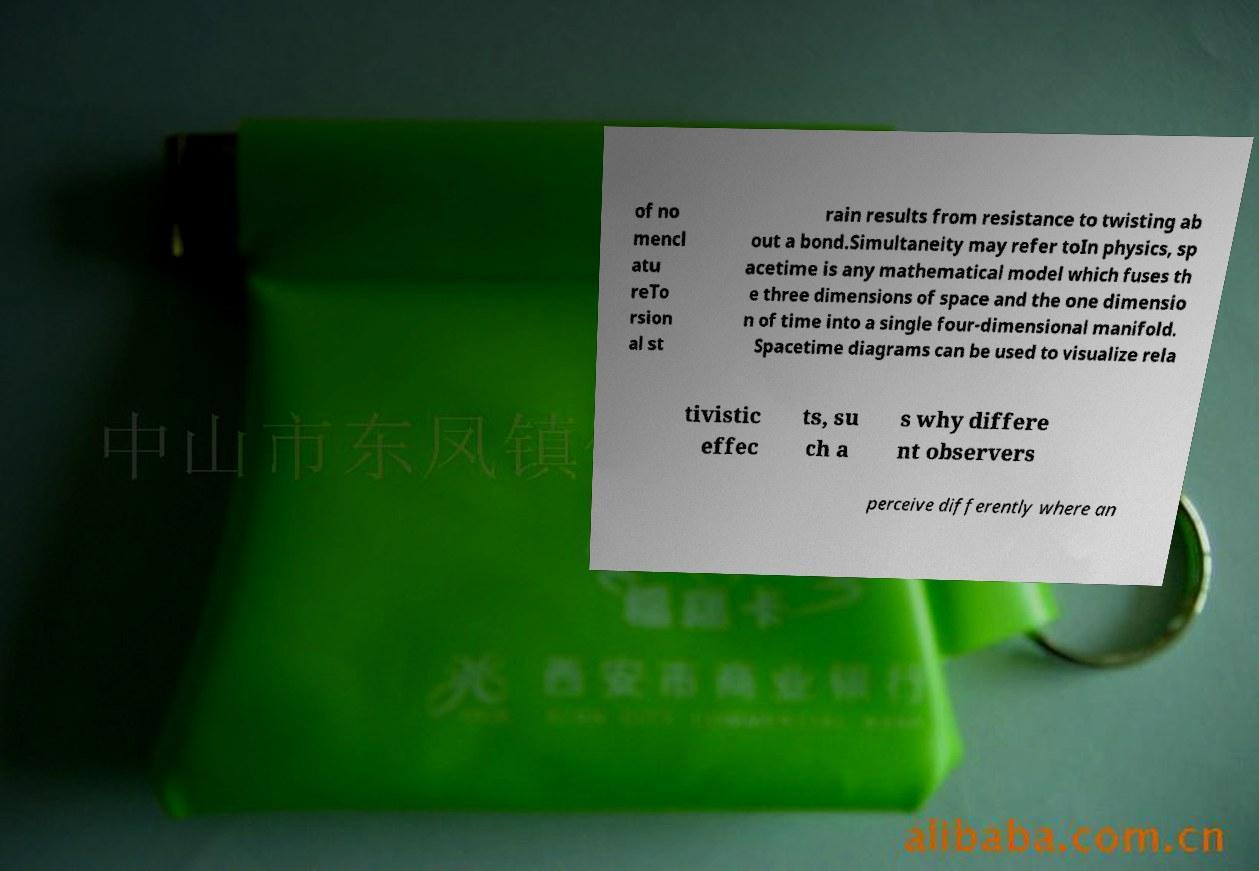Please read and relay the text visible in this image. What does it say? of no mencl atu reTo rsion al st rain results from resistance to twisting ab out a bond.Simultaneity may refer toIn physics, sp acetime is any mathematical model which fuses th e three dimensions of space and the one dimensio n of time into a single four-dimensional manifold. Spacetime diagrams can be used to visualize rela tivistic effec ts, su ch a s why differe nt observers perceive differently where an 